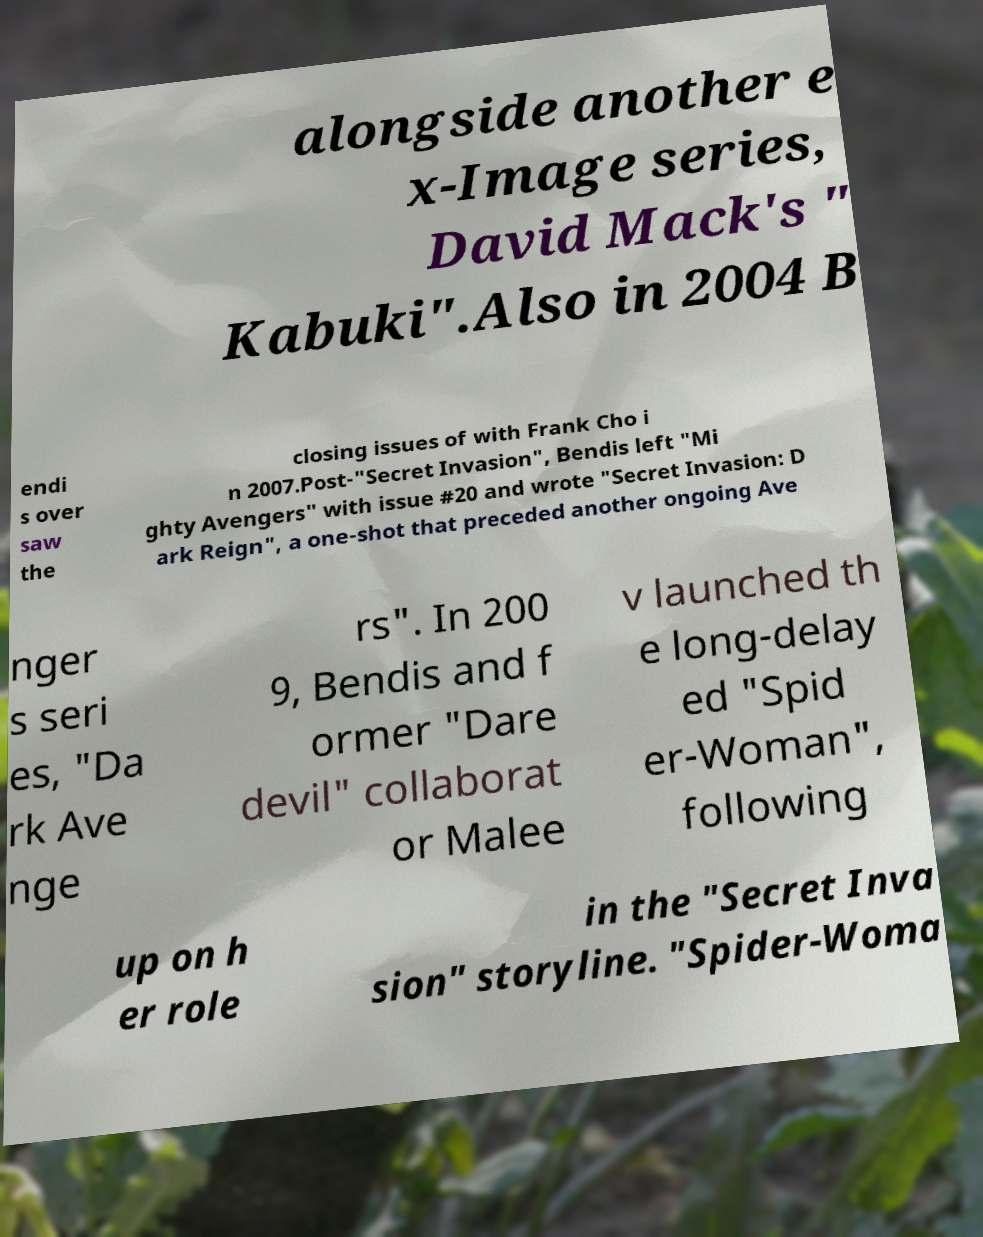For documentation purposes, I need the text within this image transcribed. Could you provide that? alongside another e x-Image series, David Mack's " Kabuki".Also in 2004 B endi s over saw the closing issues of with Frank Cho i n 2007.Post-"Secret Invasion", Bendis left "Mi ghty Avengers" with issue #20 and wrote "Secret Invasion: D ark Reign", a one-shot that preceded another ongoing Ave nger s seri es, "Da rk Ave nge rs". In 200 9, Bendis and f ormer "Dare devil" collaborat or Malee v launched th e long-delay ed "Spid er-Woman", following up on h er role in the "Secret Inva sion" storyline. "Spider-Woma 